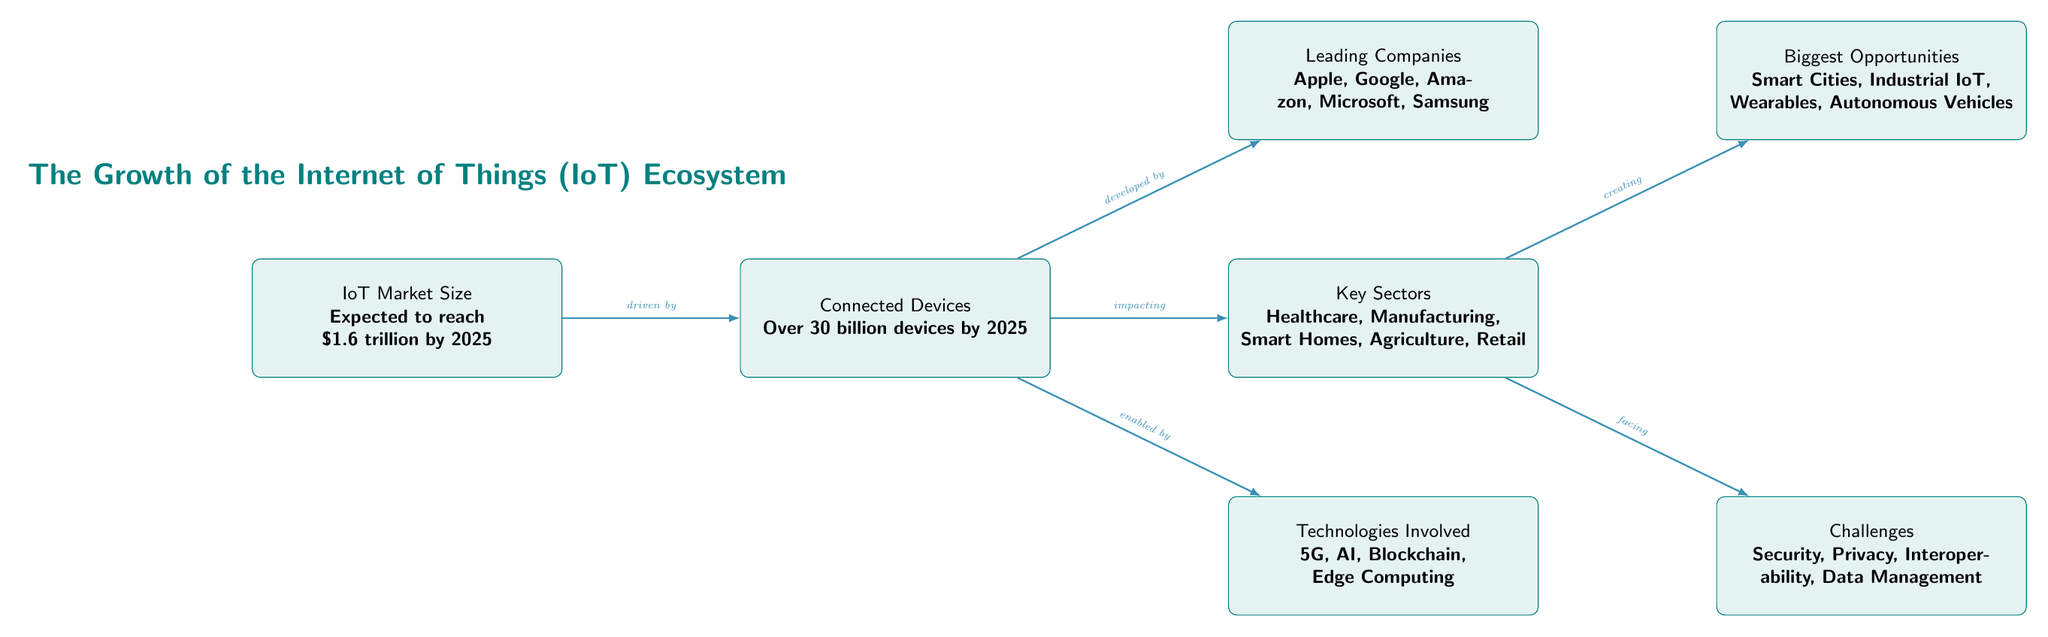What is the expected IoT market size by 2025? The diagram states that the IoT market size is expected to reach \$1.6 trillion by 2025. This information is found in the "IoT Market Size" node.
Answer: \$1.6 trillion How many connected devices are projected by 2025? According to the diagram, it indicates there will be over 30 billion connected devices by 2025, mentioned in the "Connected Devices" node.
Answer: Over 30 billion Which companies are listed as leading companies in the IoT space? The diagram specifies that Apple, Google, Amazon, Microsoft, and Samsung are the leading companies in the IoT market as highlighted in the "Leading Companies" node.
Answer: Apple, Google, Amazon, Microsoft, Samsung What technologies are involved in the IoT ecosystem? The "Technologies Involved" node specifies that 5G, AI, Blockchain, and Edge Computing are key technologies that enable IoT devices.
Answer: 5G, AI, Blockchain, Edge Computing Which sector is impacting the growth of connected devices? The diagram shows that the "Key Sectors" node is connected to "Connected Devices" and specifies that sectors like Healthcare, Manufacturing, Smart Homes, Agriculture, and Retail are impacted.
Answer: Healthcare, Manufacturing, Smart Homes, Agriculture, Retail What are the biggest opportunities in the IoT ecosystem? The "Biggest Opportunities" node indicates that Smart Cities, Industrial IoT, Wearables, and Autonomous Vehicles represent significant areas for future growth.
Answer: Smart Cities, Industrial IoT, Wearables, Autonomous Vehicles What challenges does the IoT ecosystem face? The diagram indicates the challenges in the IoT ecosystem as stated in the "Challenges" node, which includes Security, Privacy, Interoperability, and Data Management.
Answer: Security, Privacy, Interoperability, Data Management How does the increase in connected devices relate to the leading companies? The relationship stated in the diagram shows that connected devices are developed by leading companies like Apple, Google, and others, demonstrating the reliance on these firms for growth in device production.
Answer: Developed by leading companies What is the relationship between the key sectors and opportunities? According to the diagram, the "Key Sectors" create "Biggest Opportunities," indicating that different sectors' growth contributes directly to new opportunities in the IoT market.
Answer: Creating opportunities 